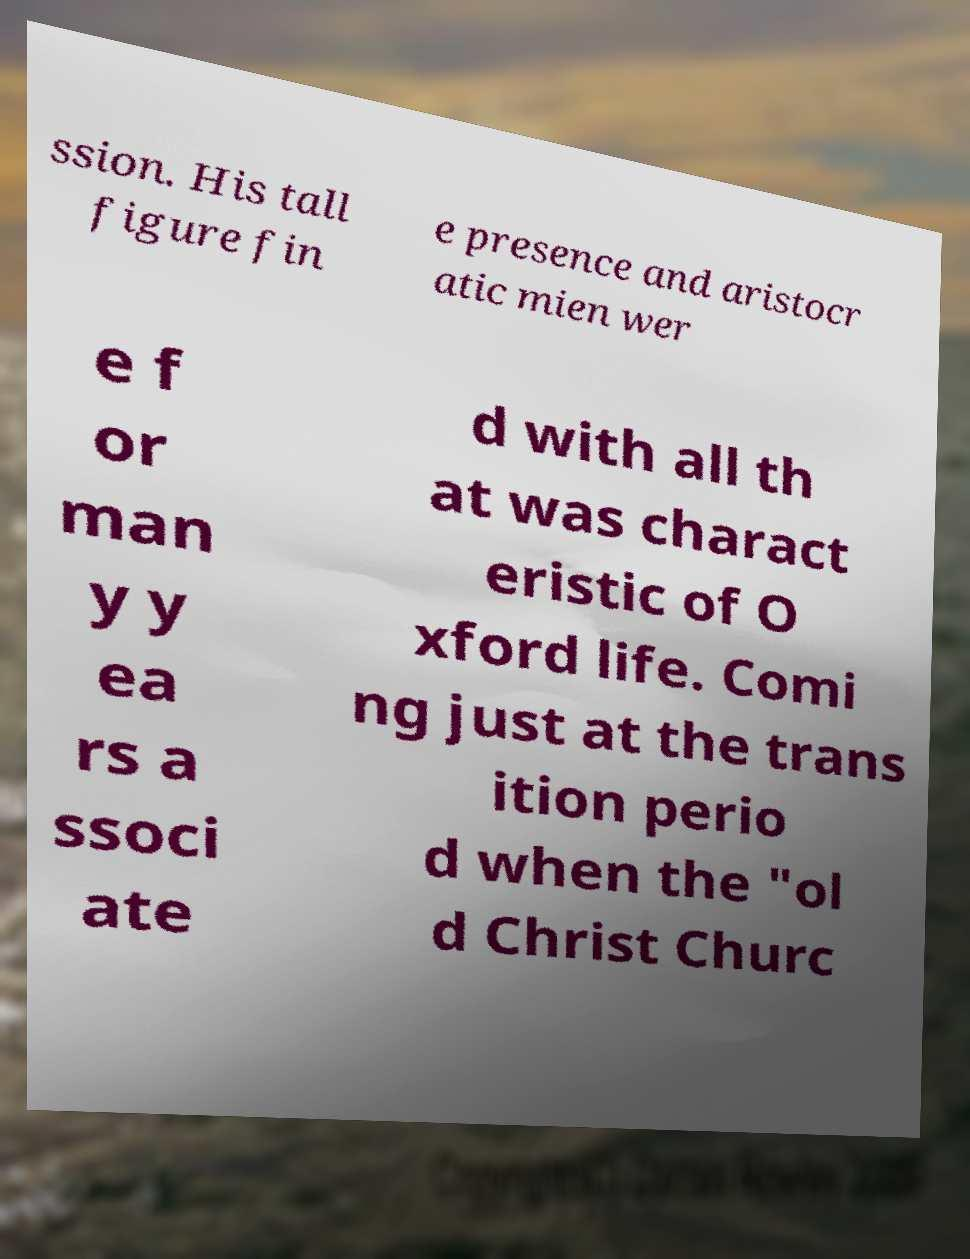Please identify and transcribe the text found in this image. ssion. His tall figure fin e presence and aristocr atic mien wer e f or man y y ea rs a ssoci ate d with all th at was charact eristic of O xford life. Comi ng just at the trans ition perio d when the "ol d Christ Churc 